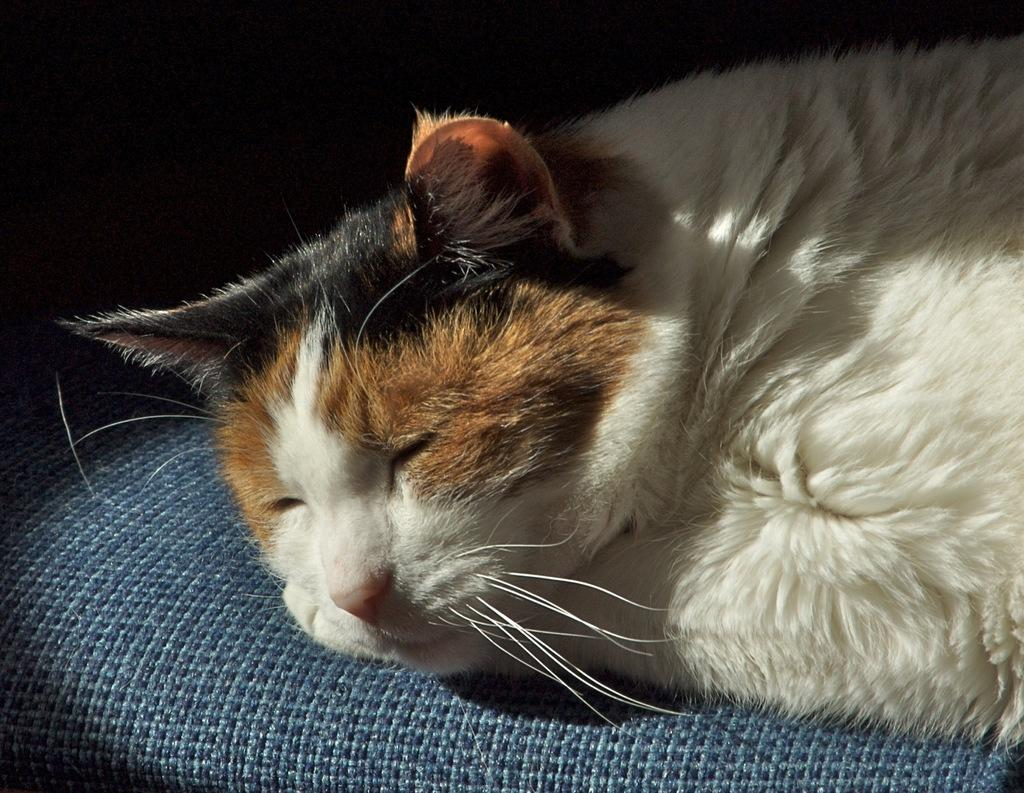What type of animal is in the image? There is a cat in the image. What is the cat doing in the image? The cat is lying on a surface. What can be observed about the background of the image? The background of the image is dark. What type of pain is the cat experiencing in the image? There is no indication in the image that the cat is experiencing any pain. 